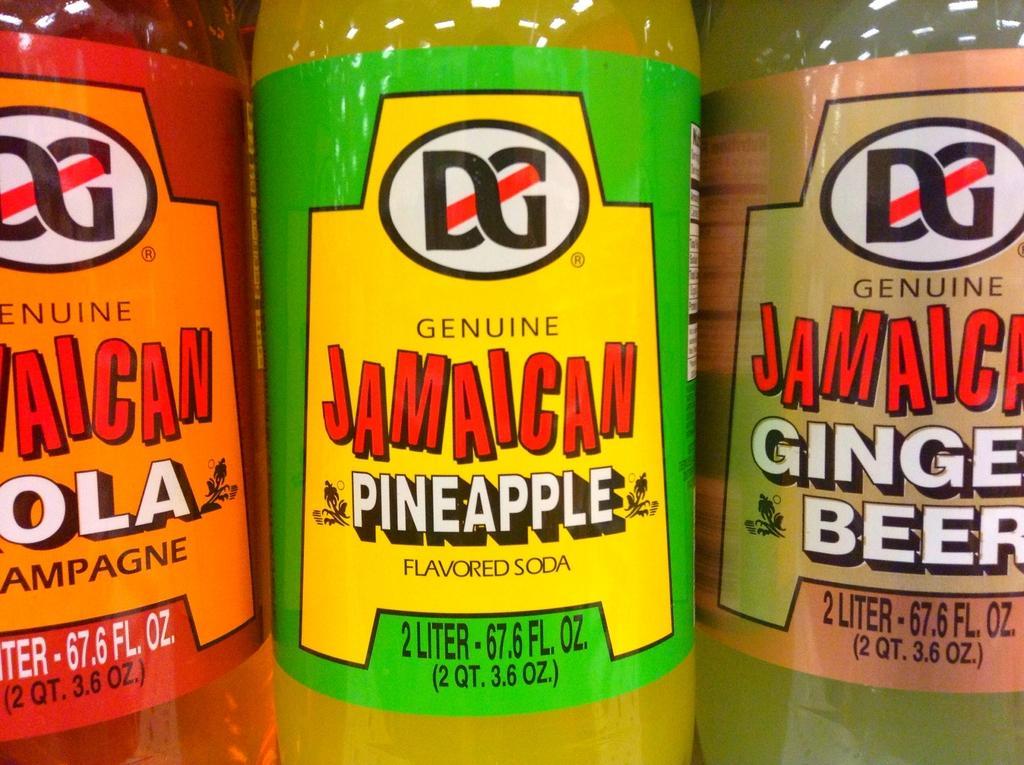How would you summarize this image in a sentence or two? In this picture, we see the cool drink bottles in red, yellow and light green color. We see the stickers pasted on the bottles, are in red, orange, green, yellow, cream and light orange color. We see some text written on the stickers. 